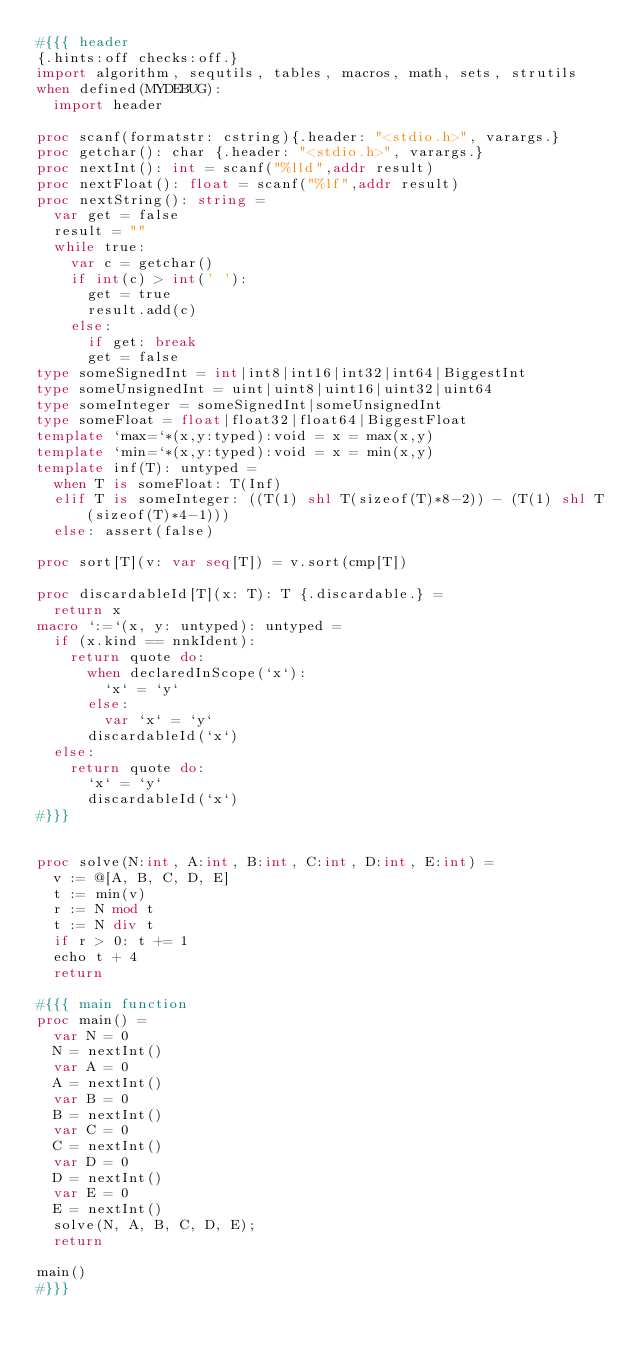<code> <loc_0><loc_0><loc_500><loc_500><_Nim_>#{{{ header
{.hints:off checks:off.}
import algorithm, sequtils, tables, macros, math, sets, strutils
when defined(MYDEBUG):
  import header

proc scanf(formatstr: cstring){.header: "<stdio.h>", varargs.}
proc getchar(): char {.header: "<stdio.h>", varargs.}
proc nextInt(): int = scanf("%lld",addr result)
proc nextFloat(): float = scanf("%lf",addr result)
proc nextString(): string =
  var get = false
  result = ""
  while true:
    var c = getchar()
    if int(c) > int(' '):
      get = true
      result.add(c)
    else:
      if get: break
      get = false
type someSignedInt = int|int8|int16|int32|int64|BiggestInt
type someUnsignedInt = uint|uint8|uint16|uint32|uint64
type someInteger = someSignedInt|someUnsignedInt
type someFloat = float|float32|float64|BiggestFloat
template `max=`*(x,y:typed):void = x = max(x,y)
template `min=`*(x,y:typed):void = x = min(x,y)
template inf(T): untyped = 
  when T is someFloat: T(Inf)
  elif T is someInteger: ((T(1) shl T(sizeof(T)*8-2)) - (T(1) shl T(sizeof(T)*4-1)))
  else: assert(false)

proc sort[T](v: var seq[T]) = v.sort(cmp[T])

proc discardableId[T](x: T): T {.discardable.} =
  return x
macro `:=`(x, y: untyped): untyped =
  if (x.kind == nnkIdent):
    return quote do:
      when declaredInScope(`x`):
        `x` = `y`
      else:
        var `x` = `y`
      discardableId(`x`)
  else:
    return quote do:
      `x` = `y`
      discardableId(`x`)
#}}}


proc solve(N:int, A:int, B:int, C:int, D:int, E:int) =
  v := @[A, B, C, D, E]
  t := min(v)
  r := N mod t
  t := N div t
  if r > 0: t += 1
  echo t + 4
  return

#{{{ main function
proc main() =
  var N = 0
  N = nextInt()
  var A = 0
  A = nextInt()
  var B = 0
  B = nextInt()
  var C = 0
  C = nextInt()
  var D = 0
  D = nextInt()
  var E = 0
  E = nextInt()
  solve(N, A, B, C, D, E);
  return

main()
#}}}
</code> 